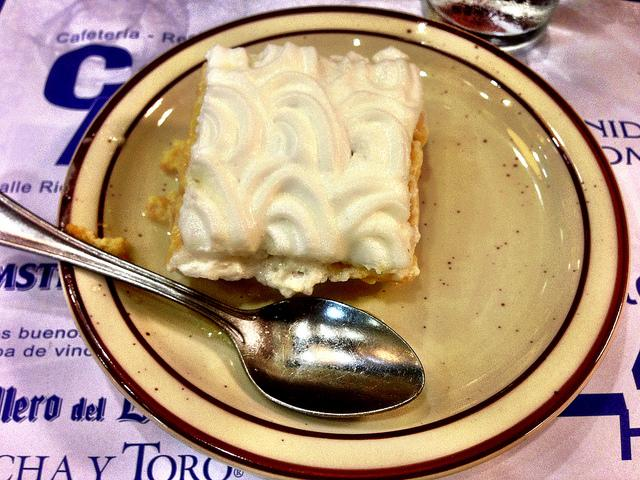What is on the plate? cake 